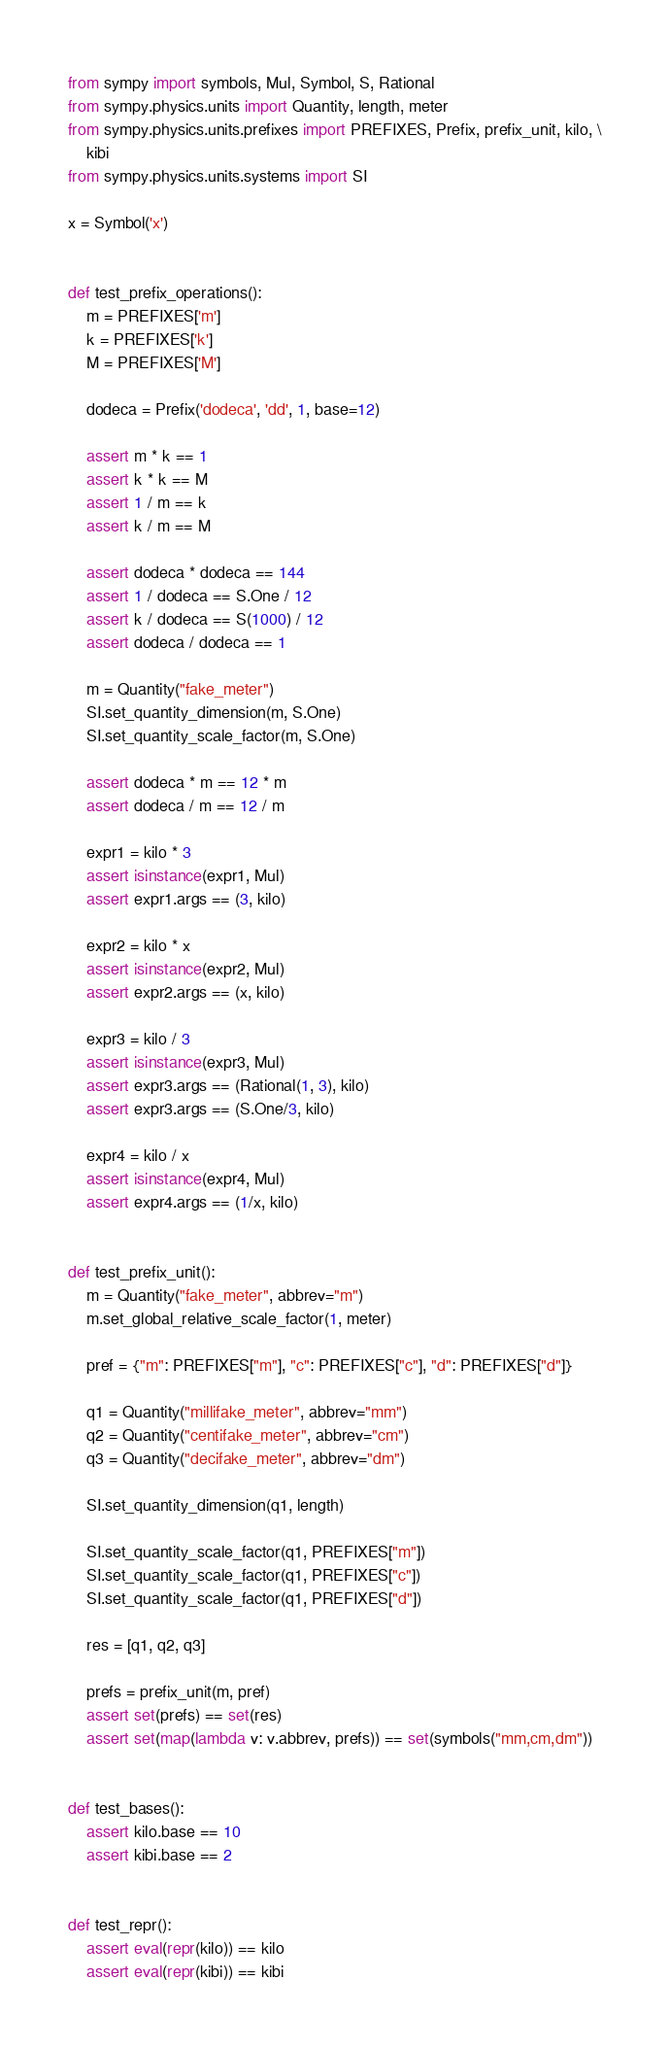Convert code to text. <code><loc_0><loc_0><loc_500><loc_500><_Python_>from sympy import symbols, Mul, Symbol, S, Rational
from sympy.physics.units import Quantity, length, meter
from sympy.physics.units.prefixes import PREFIXES, Prefix, prefix_unit, kilo, \
    kibi
from sympy.physics.units.systems import SI

x = Symbol('x')


def test_prefix_operations():
    m = PREFIXES['m']
    k = PREFIXES['k']
    M = PREFIXES['M']

    dodeca = Prefix('dodeca', 'dd', 1, base=12)

    assert m * k == 1
    assert k * k == M
    assert 1 / m == k
    assert k / m == M

    assert dodeca * dodeca == 144
    assert 1 / dodeca == S.One / 12
    assert k / dodeca == S(1000) / 12
    assert dodeca / dodeca == 1

    m = Quantity("fake_meter")
    SI.set_quantity_dimension(m, S.One)
    SI.set_quantity_scale_factor(m, S.One)

    assert dodeca * m == 12 * m
    assert dodeca / m == 12 / m

    expr1 = kilo * 3
    assert isinstance(expr1, Mul)
    assert expr1.args == (3, kilo)

    expr2 = kilo * x
    assert isinstance(expr2, Mul)
    assert expr2.args == (x, kilo)

    expr3 = kilo / 3
    assert isinstance(expr3, Mul)
    assert expr3.args == (Rational(1, 3), kilo)
    assert expr3.args == (S.One/3, kilo)

    expr4 = kilo / x
    assert isinstance(expr4, Mul)
    assert expr4.args == (1/x, kilo)


def test_prefix_unit():
    m = Quantity("fake_meter", abbrev="m")
    m.set_global_relative_scale_factor(1, meter)

    pref = {"m": PREFIXES["m"], "c": PREFIXES["c"], "d": PREFIXES["d"]}

    q1 = Quantity("millifake_meter", abbrev="mm")
    q2 = Quantity("centifake_meter", abbrev="cm")
    q3 = Quantity("decifake_meter", abbrev="dm")

    SI.set_quantity_dimension(q1, length)

    SI.set_quantity_scale_factor(q1, PREFIXES["m"])
    SI.set_quantity_scale_factor(q1, PREFIXES["c"])
    SI.set_quantity_scale_factor(q1, PREFIXES["d"])

    res = [q1, q2, q3]

    prefs = prefix_unit(m, pref)
    assert set(prefs) == set(res)
    assert set(map(lambda v: v.abbrev, prefs)) == set(symbols("mm,cm,dm"))


def test_bases():
    assert kilo.base == 10
    assert kibi.base == 2


def test_repr():
    assert eval(repr(kilo)) == kilo
    assert eval(repr(kibi)) == kibi
</code> 